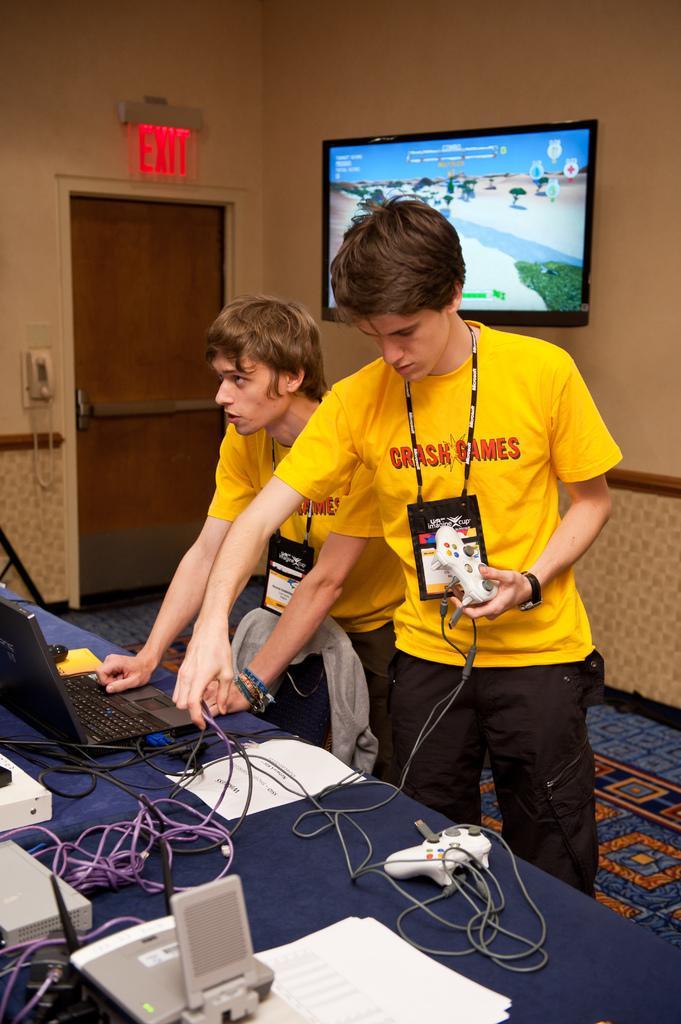Can you describe this image briefly? In this picture we can see a person holding an object in his hand. There is a laptop,wires and few devices on the table. We can see a telephone and an EXIT sign board on the wall. There is a Television on the wall. We can see a door in the background. 